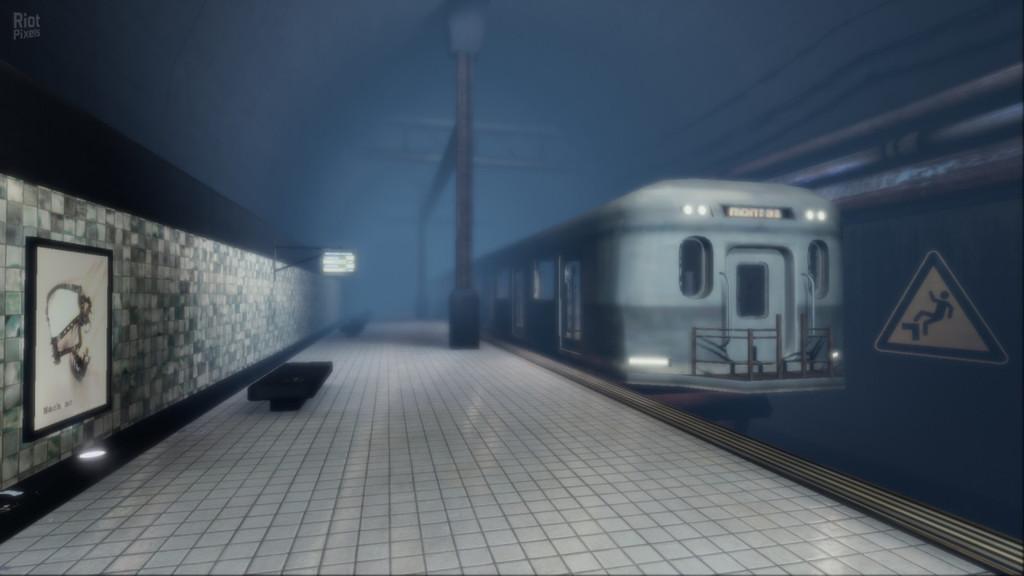Can you describe this image briefly? In this image we can see a train and in front there is a sign board and to the side, we can see the platform and there is a bench and a pole on the platform. We can see a wall with a poster and there is a picture on it and we can see a light attached to the wall. 